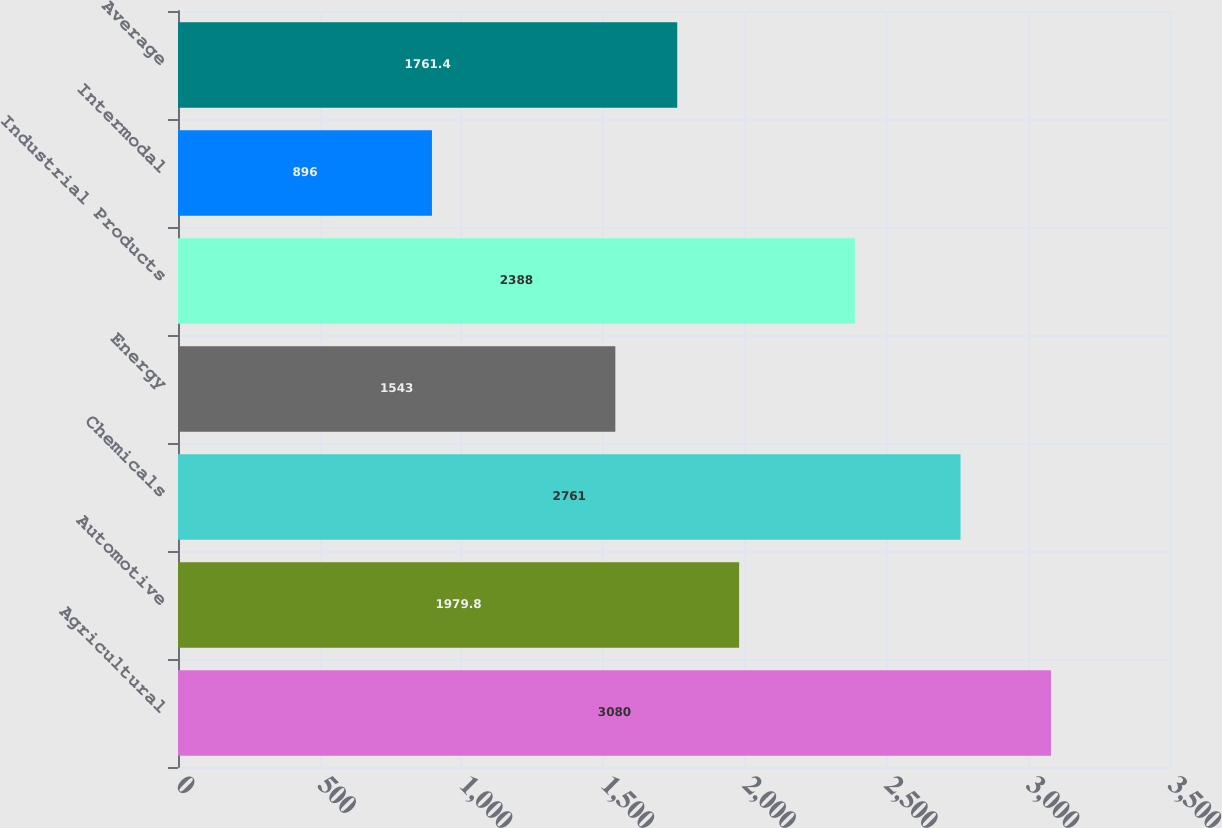Convert chart. <chart><loc_0><loc_0><loc_500><loc_500><bar_chart><fcel>Agricultural<fcel>Automotive<fcel>Chemicals<fcel>Energy<fcel>Industrial Products<fcel>Intermodal<fcel>Average<nl><fcel>3080<fcel>1979.8<fcel>2761<fcel>1543<fcel>2388<fcel>896<fcel>1761.4<nl></chart> 